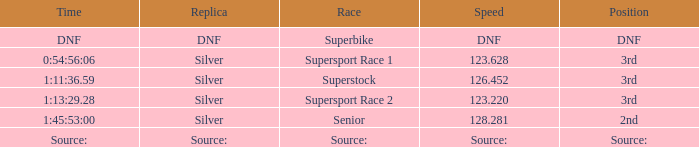Which position has a time of 1:45:53:00? 2nd. 